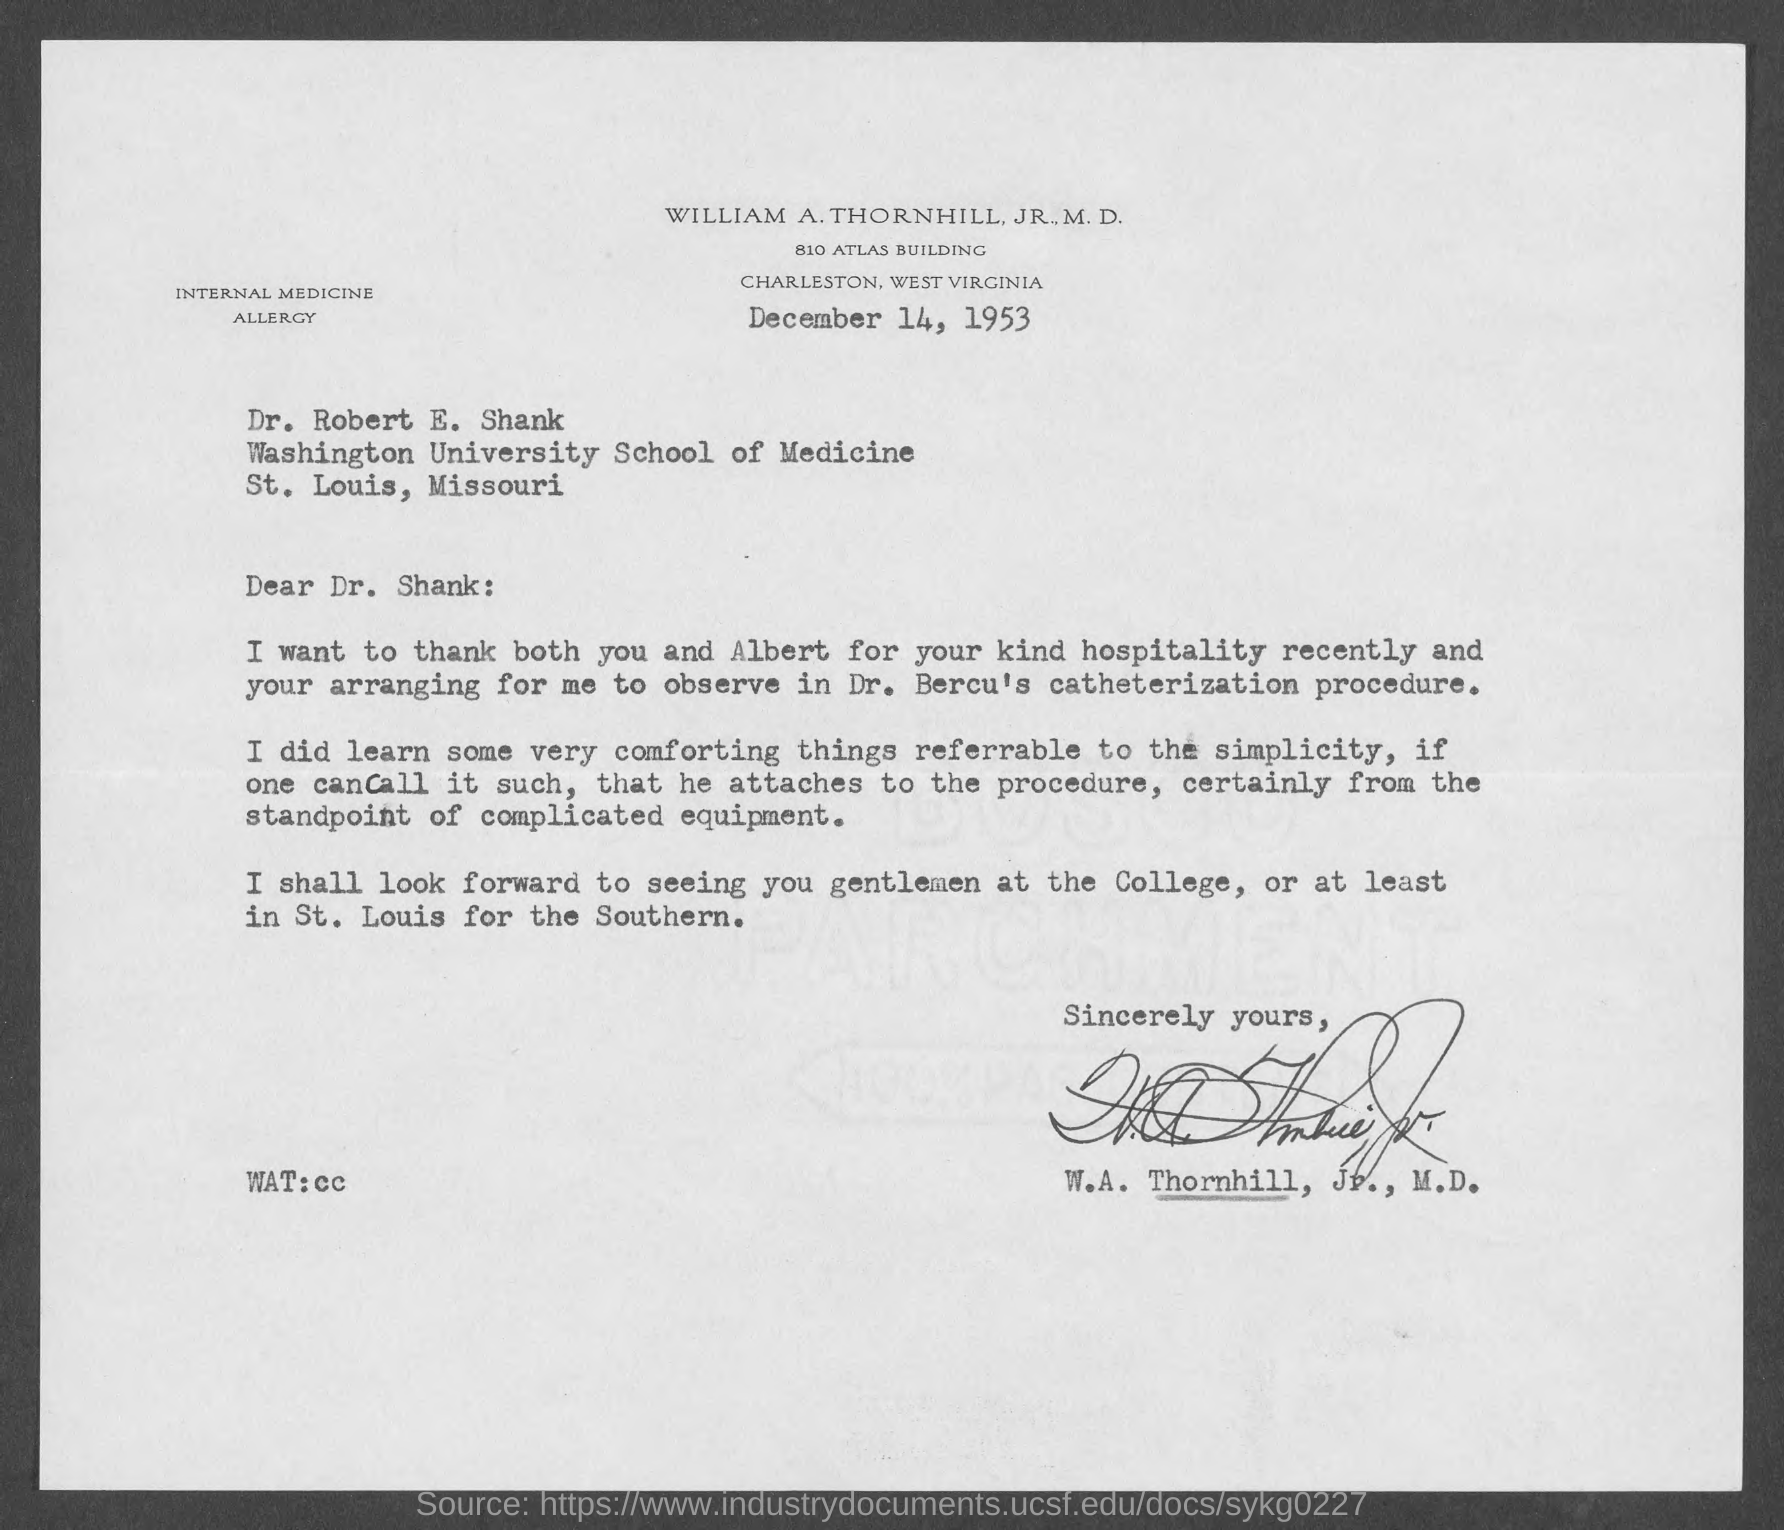Draw attention to some important aspects in this diagram. This letter is addressed to Dr. Robert E. Shank. The letter is dated December 14, 1953. 